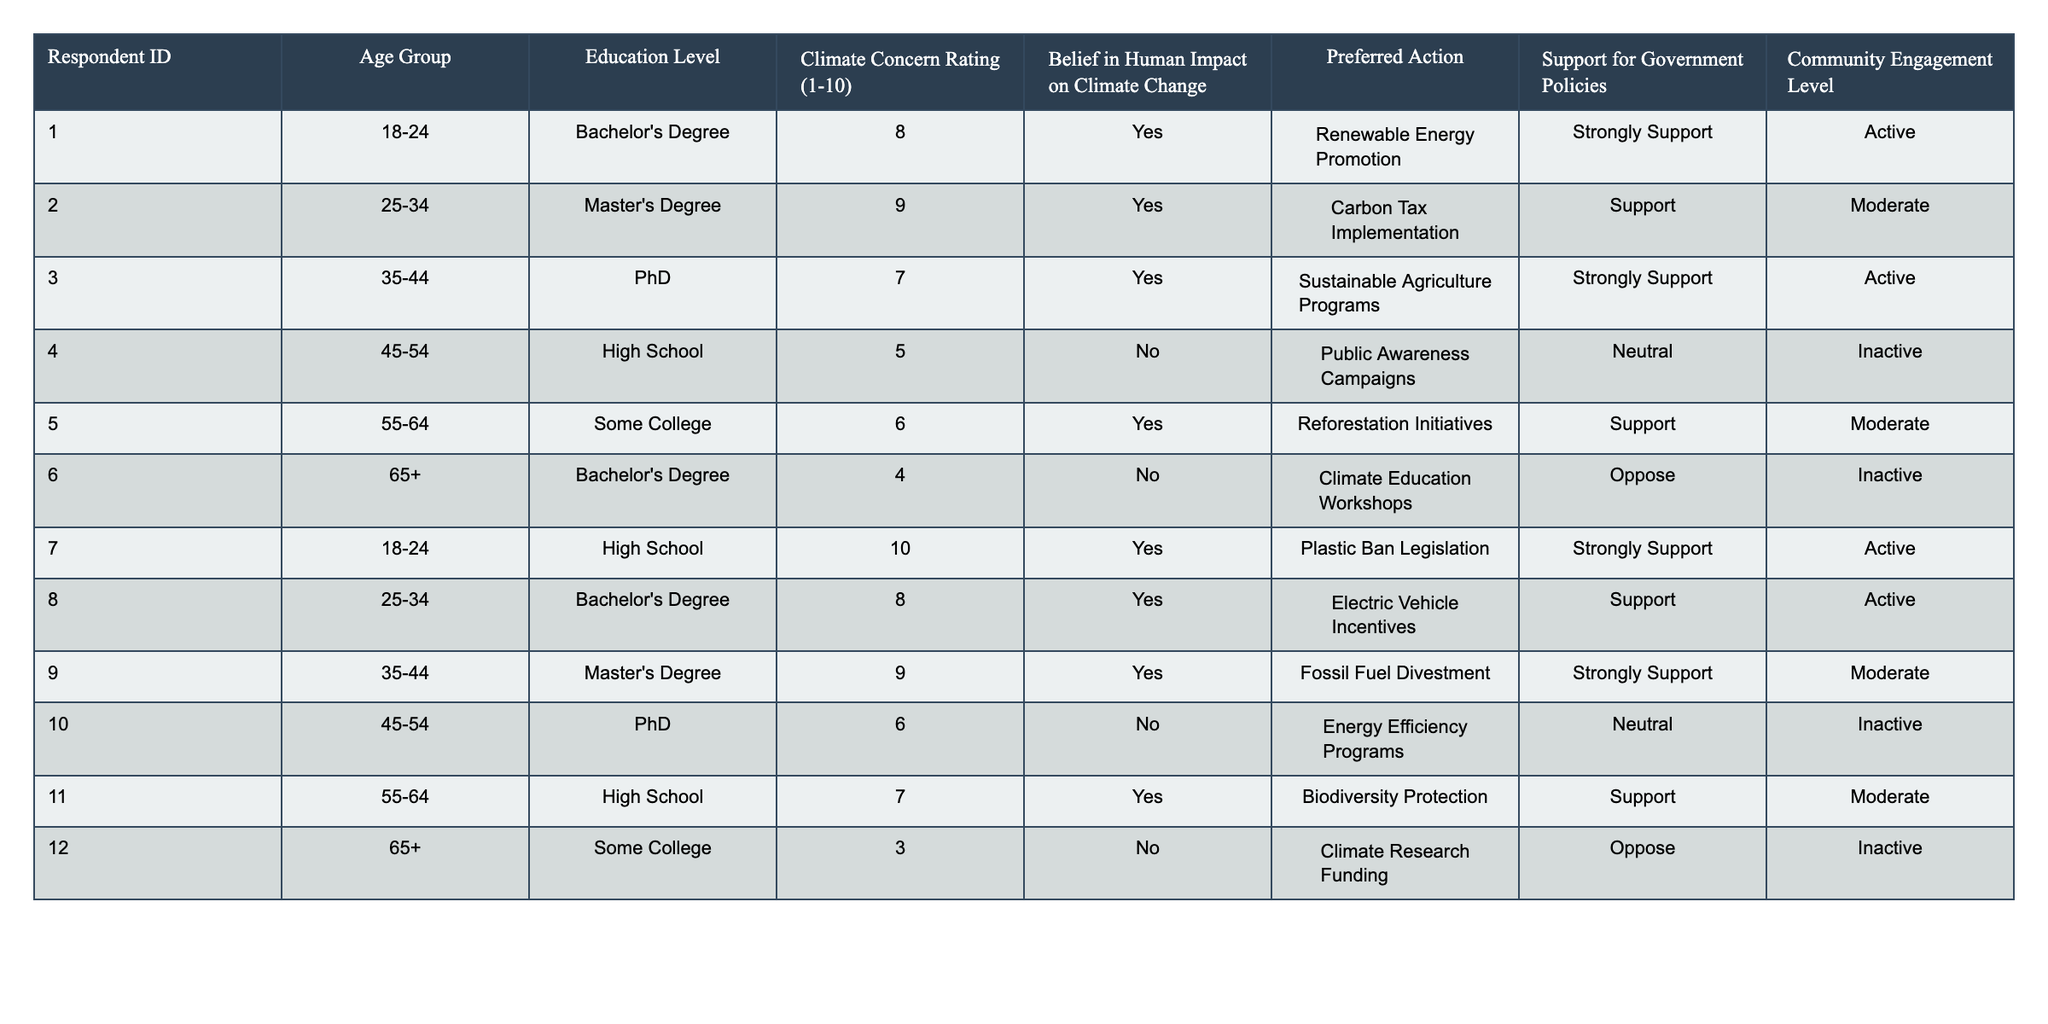What is the Climate Concern Rating of Respondent ID 7? The Climate Concern Rating is explicitly listed in the table for Respondent ID 7 as 10.
Answer: 10 Which Age Group has the highest average Climate Concern Rating? The Climate Concern Ratings for each Age Group are: 18-24 (8.5), 25-34 (8.5), 35-44 (8.5), 45-54 (5.5), 55-64 (6.5), and 65+ (3.5). The highest average is 8.5 for the 18-24, 25-34, and 35-44 Age Groups.
Answer: 18-24, 25-34, and 35-44 Do any respondents with a High School education level believe in human impact on climate change? Checking the table shows that among the respondents with a High School education level, Respondent IDs 4 and 11 did not express a belief in human impact on climate change. Therefore, no respondents with a High School education level believe in it.
Answer: No What is the preferred action for the respondent who is 65+ years old? Respondent ID 12 is the only one in the 65+ age group, and their preferred action is "Climate Research Funding," as it can be found in the table.
Answer: Climate Research Funding How many respondents support government policies related to climate change? Counting the support levels in the table reveals that 6 respondents either "Strongly Support" or "Support" government policies.
Answer: 6 Is there a correlation between age group and the support for government policies? This requires examining each age group and their corresponding support levels in the table. The age group with the highest support ("Strongly Support") were younger respondents, while older age groups tended to "Oppose" or remain "Neutral."
Answer: Yes, younger age groups tend to support more Which education level has the highest Climate Concern Rating? The highest Climate Concern Rating is 10 from a respondent with a High School education level (ID 7), making it the highest among other education levels listed.
Answer: High School How many respondents actively engage with their community regarding climate change? There are three respondents identified as "Active" in the table, specifically Respondent IDs 1, 3, 7, and 8. Counting these shows that 4 respondents engage actively in their communities.
Answer: 4 What is the least supported preferred action among those who do not believe in human impact on climate change? Among respondents who do not believe in human impact (IDs 4 and 6), the least supported action is "Climate Education Workshops," which has an "Oppose" support level, whereas the only other action is a "Neutral" campaign.
Answer: Climate Education Workshops What is the median Climate Concern Rating of the respondents? First, list the Climate Concern Ratings: 3, 4, 5, 6, 6, 7, 7, 8, 8, 9, 9, and 10. The median value, being the average of the 6th and 7th values (7 and 7), is 7.
Answer: 7 